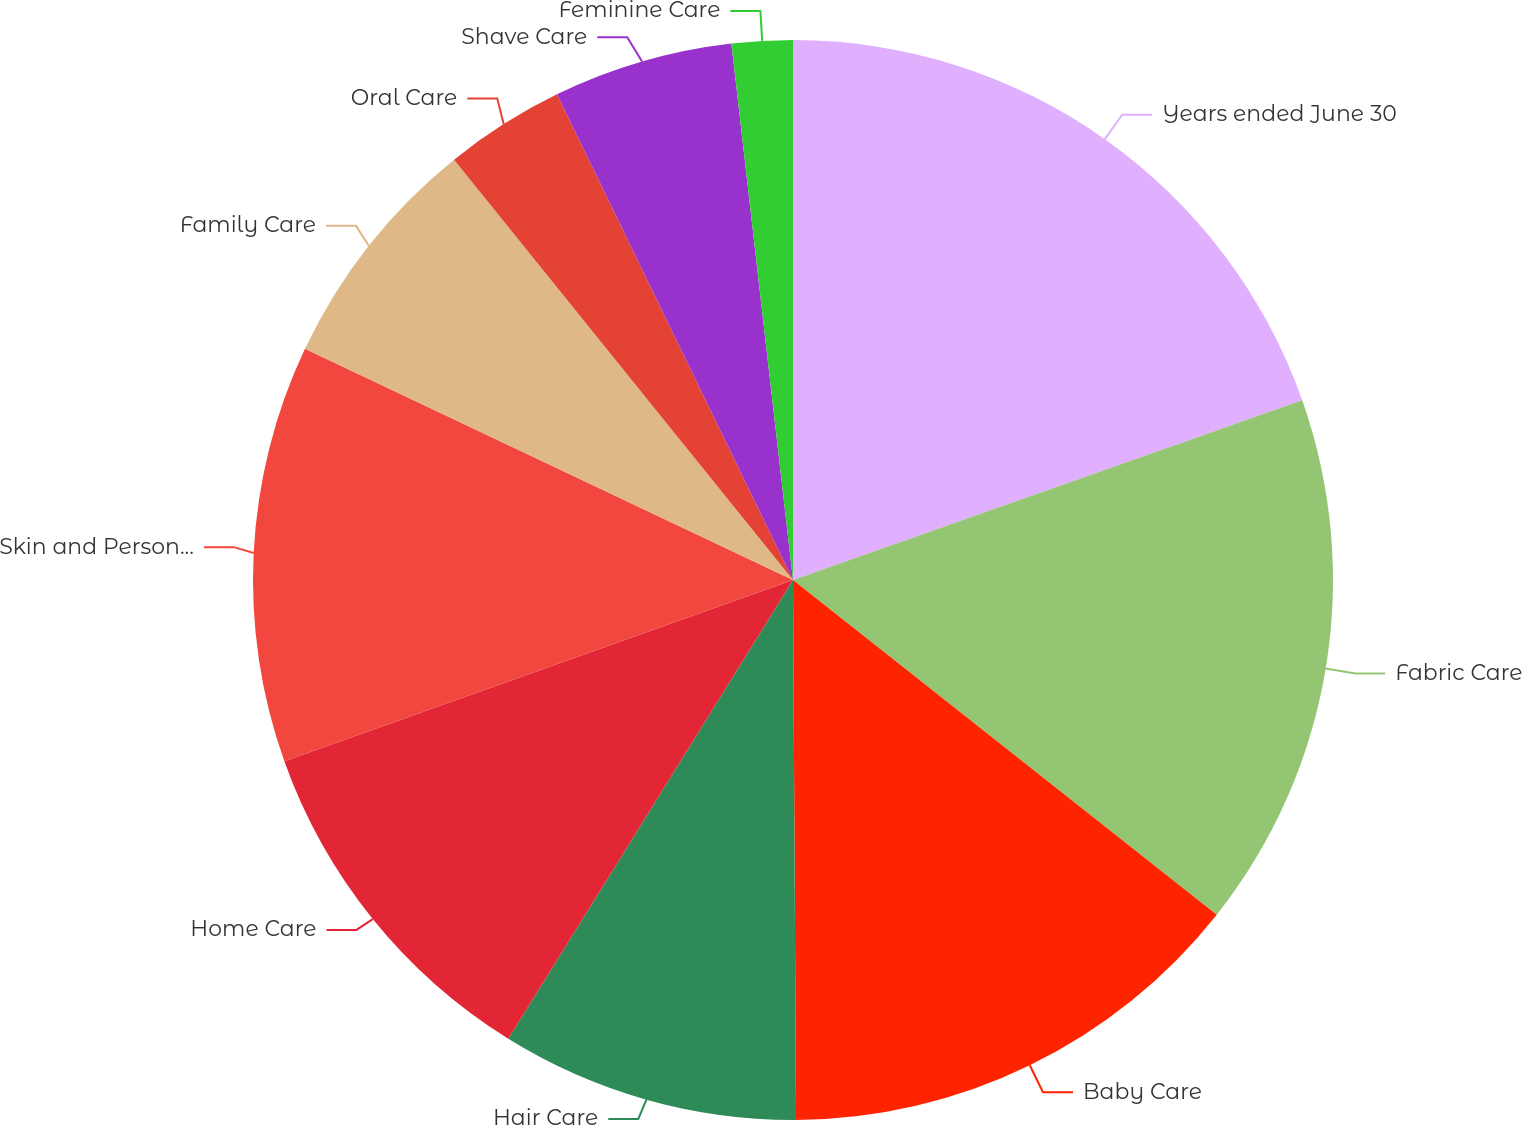<chart> <loc_0><loc_0><loc_500><loc_500><pie_chart><fcel>Years ended June 30<fcel>Fabric Care<fcel>Baby Care<fcel>Hair Care<fcel>Home Care<fcel>Skin and Personal Care<fcel>Family Care<fcel>Oral Care<fcel>Shave Care<fcel>Feminine Care<nl><fcel>19.6%<fcel>16.04%<fcel>14.27%<fcel>8.93%<fcel>10.71%<fcel>12.49%<fcel>7.16%<fcel>3.6%<fcel>5.38%<fcel>1.82%<nl></chart> 